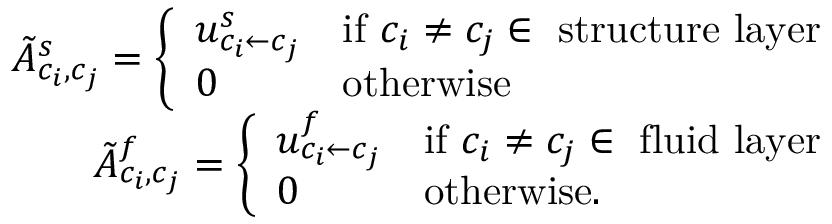Convert formula to latex. <formula><loc_0><loc_0><loc_500><loc_500>\begin{array} { r } { \tilde { A } _ { c _ { i } , c _ { j } } ^ { s } = \left \{ \begin{array} { l l } { u _ { { c _ { i } } \leftarrow { c _ { j } } } ^ { s } } & { i f c _ { i } \neq c _ { j } \in s t r u c t u r e l a y e r } \\ { 0 } & { o t h e r w i s e } \end{array} } \\ { \tilde { A } _ { c _ { i } , c _ { j } } ^ { f } = \left \{ \begin{array} { l l } { u _ { { c _ { i } } \leftarrow { c _ { j } } } ^ { f } } & { i f c _ { i } \neq c _ { j } \in f l u i d l a y e r } \\ { 0 } & { o t h e r w i s e . } \end{array} } \end{array}</formula> 